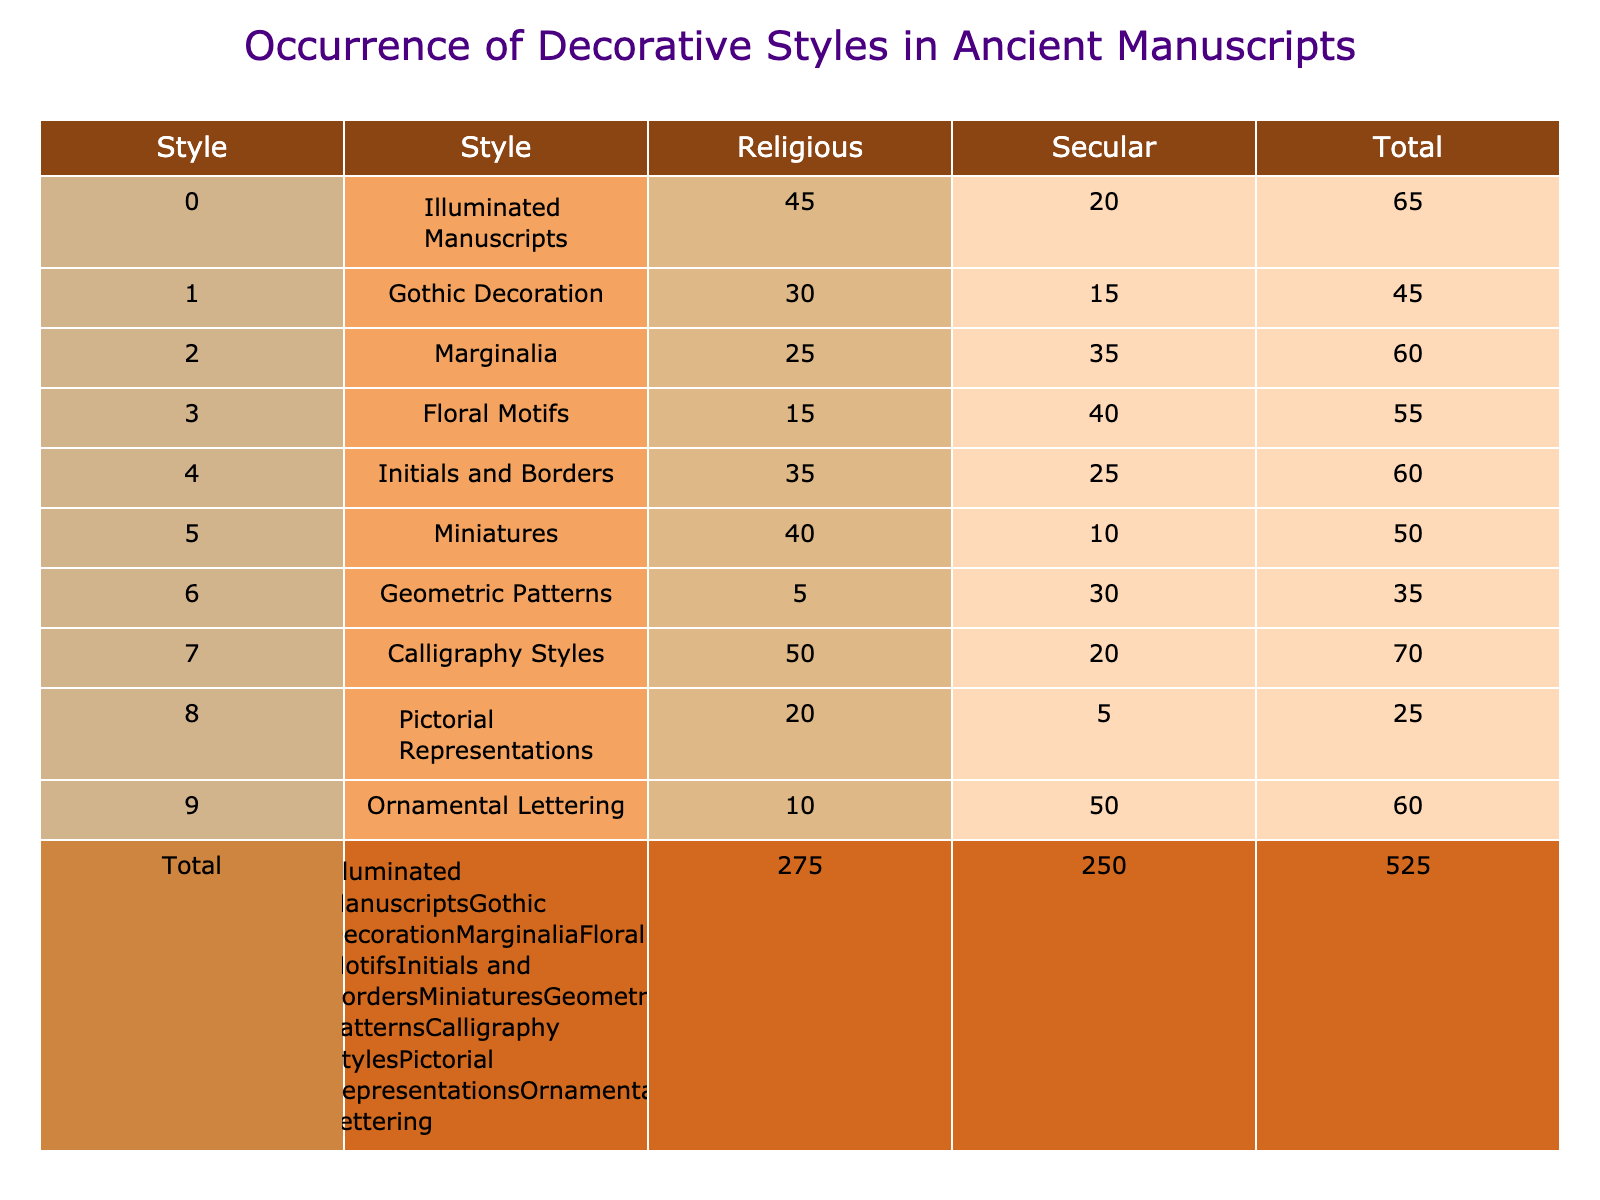What decorative style has the highest occurrence in religious manuscripts? In the table, you can look at the "Religious" column and identify the highest value. Illuminated Manuscripts have a value of 45, which is higher than any other style listed.
Answer: Illuminated Manuscripts What is the total number of secular manuscripts that feature Gothic Decoration? For Gothic Decoration, the table shows a value of 15 under the "Secular" column, which directly answers the question.
Answer: 15 True or False: The number of Floral Motifs in secular manuscripts is greater than in religious manuscripts. Looking at the table in the "Floral Motifs" row, the secular value is 40, while the religious value is 15. Since 40 is greater than 15, the statement is true.
Answer: True What is the combined total of Miniatures in both religious and secular manuscripts? You sum the values in the "Religious" (40) and "Secular" (10) columns for Miniatures: 40 + 10 = 50. This provides the combined total.
Answer: 50 Which decorative style has the highest discrepancy between religious and secular occurrences? To find the discrepancy, you calculate the absolute differences between the religious and secular occurrences for each style. The highest discrepancy is found with Ornamental Lettering, where there are 10 religious occurrences and 50 secular occurrences, giving an absolute difference of 40.
Answer: Ornamental Lettering What is the average occurrence of decorative styles in religious manuscripts? To find the average, first sum all the "Religious" values: 45 + 30 + 25 + 15 + 35 + 40 + 5 + 50 + 20 + 10 = 355. There are 10 styles total, so you divide 355 by 10: 355/10 = 35.5.
Answer: 35.5 Which style has the least presence in secular manuscripts? In the "Secular" column, the least value is for Pictorial Representations, which is 5. This identifies the style with the lowest occurrence in secular manuscripts.
Answer: Pictorial Representations Is the number of manuscripts featuring Calligraphy Styles in religious manuscripts equal to the sum of Miniatures and Geometric Patterns in secular manuscripts? For Calligraphy Styles in religious manuscripts, the number is 50. For the other two styles in secular manuscripts, Miniatures has 10 and Geometric Patterns has 30. Summing those gives 10 + 30 = 40, which is not equal to 50, making the statement false.
Answer: False 